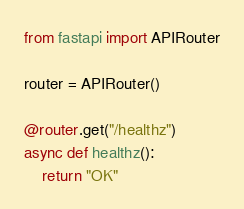Convert code to text. <code><loc_0><loc_0><loc_500><loc_500><_Python_>
from fastapi import APIRouter

router = APIRouter()

@router.get("/healthz")
async def healthz():
    return "OK"
</code> 